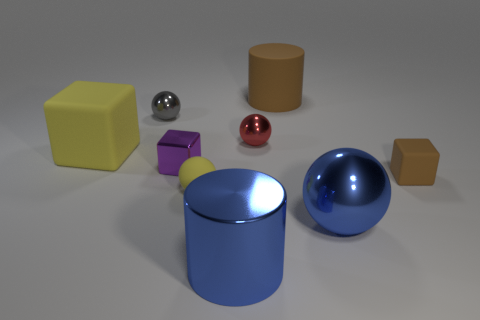There is a rubber thing that is the same color as the big rubber cylinder; what size is it?
Offer a very short reply. Small. Is there another object that has the same shape as the big yellow rubber thing?
Give a very brief answer. Yes. There is a block that is the same size as the blue metallic cylinder; what color is it?
Ensure brevity in your answer.  Yellow. Are there fewer blocks that are to the left of the small red thing than large yellow objects right of the large brown rubber thing?
Keep it short and to the point. No. There is a yellow object behind the yellow rubber ball; is its size the same as the small brown matte object?
Your answer should be very brief. No. The yellow rubber object that is to the right of the big yellow block has what shape?
Your response must be concise. Sphere. Is the number of tiny brown rubber things greater than the number of red blocks?
Keep it short and to the point. Yes. Is the color of the rubber block that is left of the gray shiny sphere the same as the tiny rubber cube?
Keep it short and to the point. No. How many objects are spheres in front of the yellow cube or small blocks on the left side of the tiny brown rubber object?
Provide a succinct answer. 3. How many matte objects are both behind the tiny yellow object and to the left of the big blue cylinder?
Your answer should be very brief. 1. 